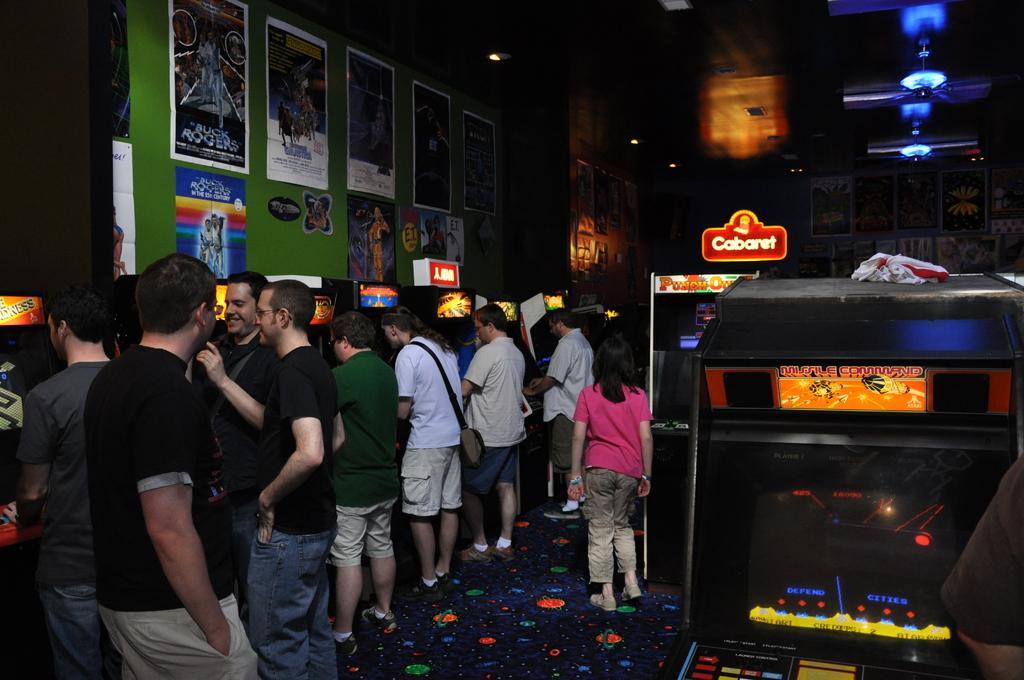Can you describe this image briefly? On the left we can see people standing at video game counters. At the top there are posters, light, chandelier, ceiling and other object. On the right we can see video game boxes. At the bottom it is floor. 